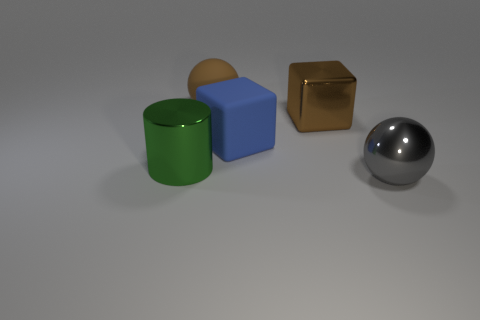Subtract 2 balls. How many balls are left? 0 Add 4 green matte things. How many objects exist? 9 Add 4 large green metallic cylinders. How many large green metallic cylinders exist? 5 Subtract 1 brown blocks. How many objects are left? 4 Subtract all spheres. How many objects are left? 3 Subtract all brown spheres. Subtract all red cylinders. How many spheres are left? 1 Subtract all small purple rubber cylinders. Subtract all brown rubber objects. How many objects are left? 4 Add 5 balls. How many balls are left? 7 